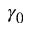<formula> <loc_0><loc_0><loc_500><loc_500>\gamma _ { 0 }</formula> 